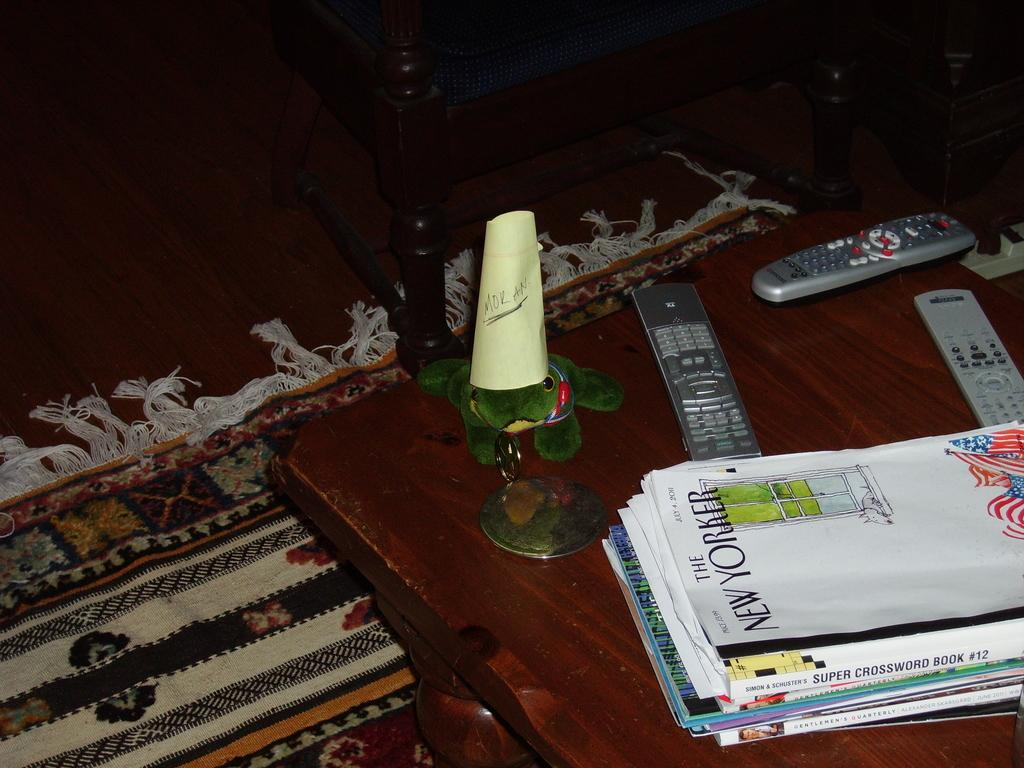<image>
Share a concise interpretation of the image provided. A wooden coffee table contains remote controls, a pile of magazines topped by "The New Yorker", and a frog wearing a paper cone that has "Moran" written on it. 